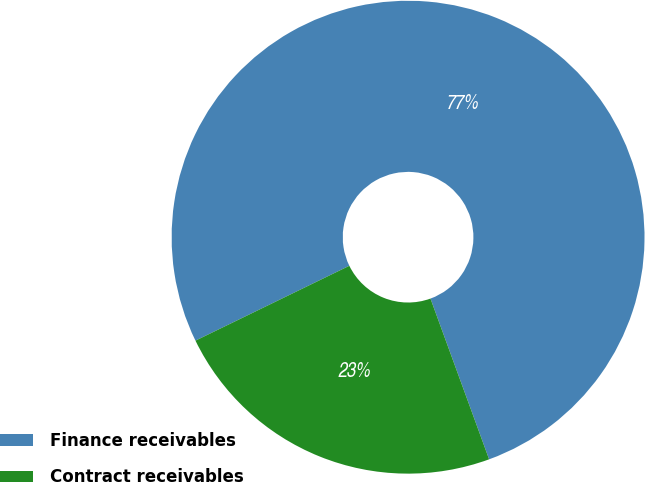<chart> <loc_0><loc_0><loc_500><loc_500><pie_chart><fcel>Finance receivables<fcel>Contract receivables<nl><fcel>76.64%<fcel>23.36%<nl></chart> 